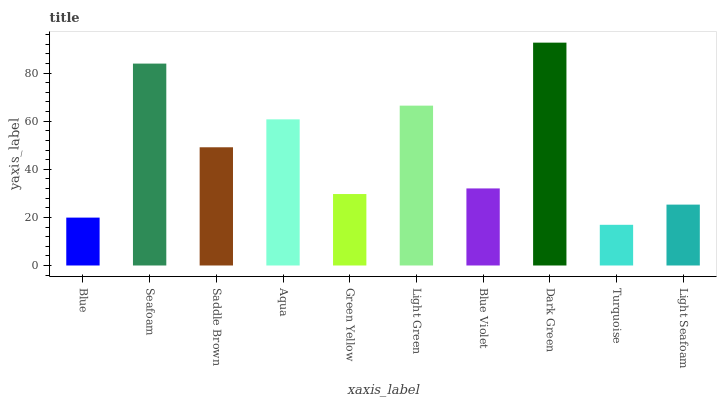Is Turquoise the minimum?
Answer yes or no. Yes. Is Dark Green the maximum?
Answer yes or no. Yes. Is Seafoam the minimum?
Answer yes or no. No. Is Seafoam the maximum?
Answer yes or no. No. Is Seafoam greater than Blue?
Answer yes or no. Yes. Is Blue less than Seafoam?
Answer yes or no. Yes. Is Blue greater than Seafoam?
Answer yes or no. No. Is Seafoam less than Blue?
Answer yes or no. No. Is Saddle Brown the high median?
Answer yes or no. Yes. Is Blue Violet the low median?
Answer yes or no. Yes. Is Turquoise the high median?
Answer yes or no. No. Is Seafoam the low median?
Answer yes or no. No. 